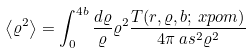Convert formula to latex. <formula><loc_0><loc_0><loc_500><loc_500>\left < \varrho ^ { 2 } \right > & = \int _ { 0 } ^ { 4 b } \frac { d \varrho } { \varrho } \varrho ^ { 2 } \frac { T ( r , \varrho , b ; \ x p o m ) } { 4 \pi \ a s ^ { 2 } \varrho ^ { 2 } }</formula> 